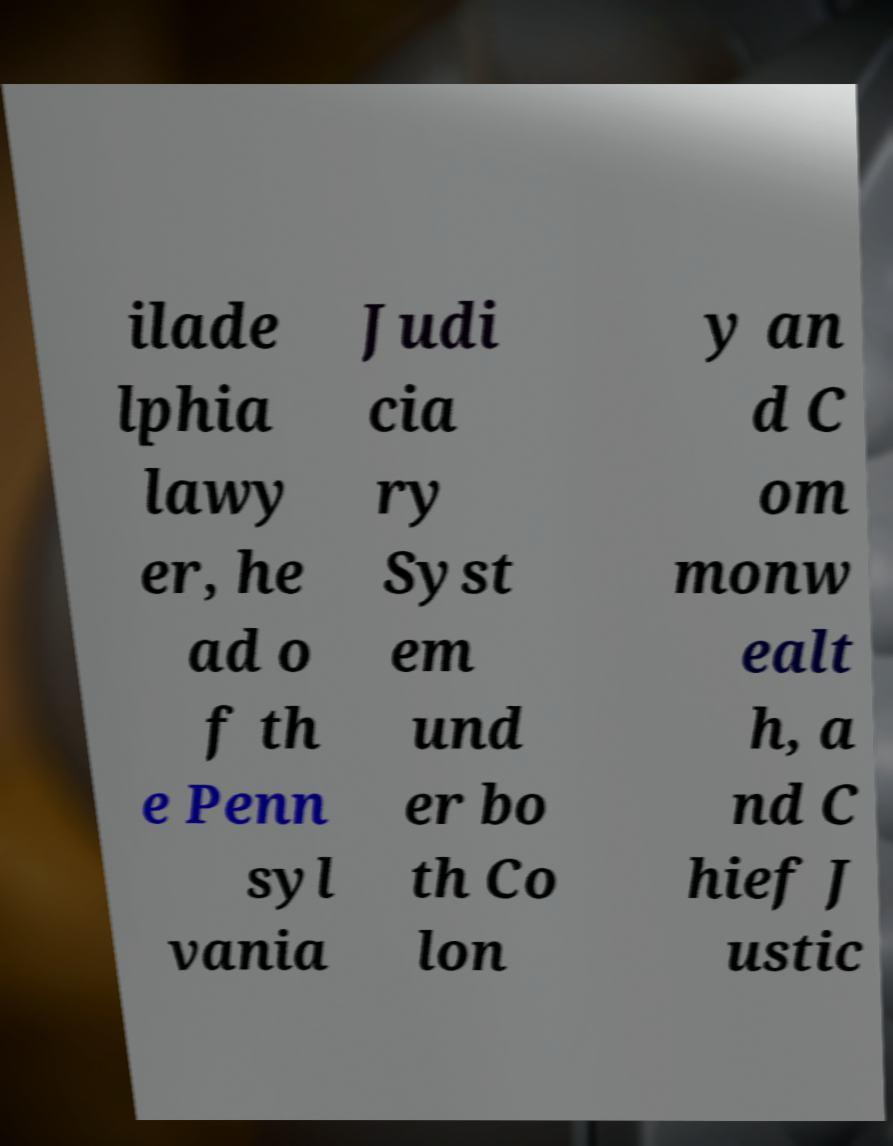There's text embedded in this image that I need extracted. Can you transcribe it verbatim? ilade lphia lawy er, he ad o f th e Penn syl vania Judi cia ry Syst em und er bo th Co lon y an d C om monw ealt h, a nd C hief J ustic 